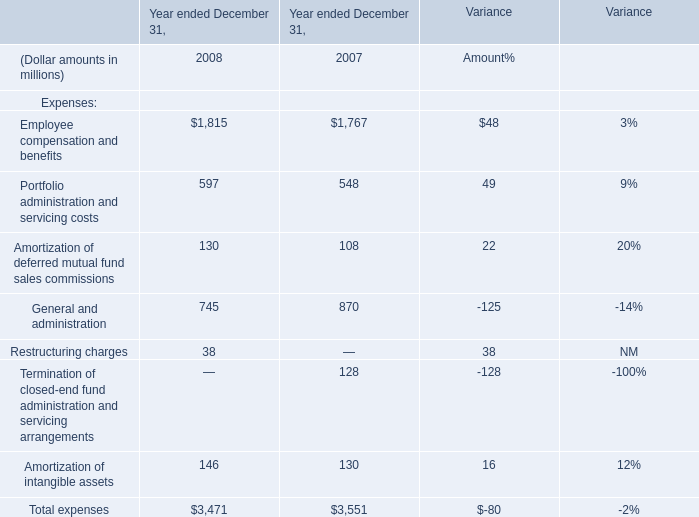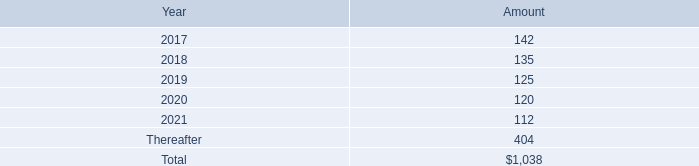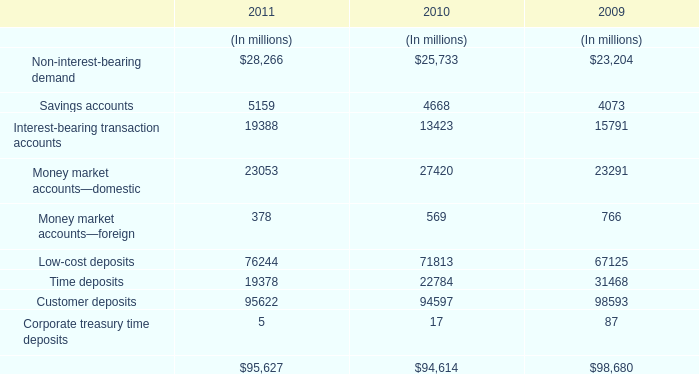What's the average of Employee compensation and benefits and Portfolio administration and servicing costs and Amortization of deferred mutual fund sales commissions in 2008? (in million) 
Computations: (((1815 + 597) + 130) / 3)
Answer: 847.33333. 